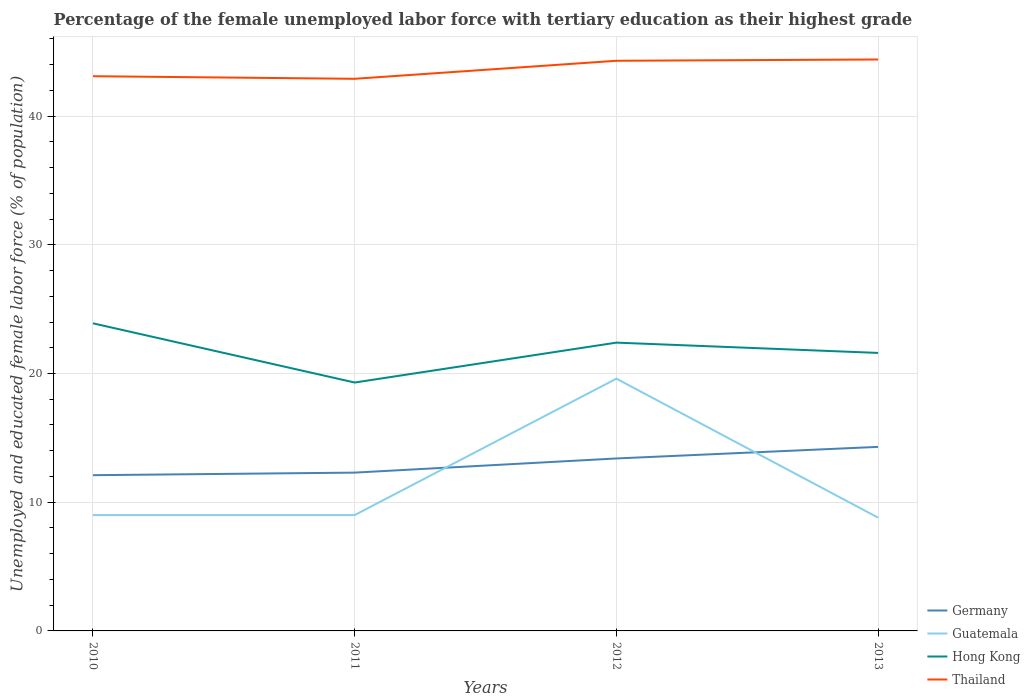How many different coloured lines are there?
Offer a very short reply. 4. Does the line corresponding to Germany intersect with the line corresponding to Thailand?
Keep it short and to the point. No. Is the number of lines equal to the number of legend labels?
Provide a short and direct response. Yes. Across all years, what is the maximum percentage of the unemployed female labor force with tertiary education in Hong Kong?
Provide a short and direct response. 19.3. What is the total percentage of the unemployed female labor force with tertiary education in Germany in the graph?
Offer a terse response. -0.9. What is the difference between the highest and the lowest percentage of the unemployed female labor force with tertiary education in Thailand?
Ensure brevity in your answer.  2. How many years are there in the graph?
Provide a short and direct response. 4. Are the values on the major ticks of Y-axis written in scientific E-notation?
Make the answer very short. No. Does the graph contain any zero values?
Provide a short and direct response. No. Does the graph contain grids?
Give a very brief answer. Yes. Where does the legend appear in the graph?
Ensure brevity in your answer.  Bottom right. How many legend labels are there?
Your answer should be compact. 4. What is the title of the graph?
Your answer should be very brief. Percentage of the female unemployed labor force with tertiary education as their highest grade. What is the label or title of the X-axis?
Provide a short and direct response. Years. What is the label or title of the Y-axis?
Your response must be concise. Unemployed and educated female labor force (% of population). What is the Unemployed and educated female labor force (% of population) in Germany in 2010?
Keep it short and to the point. 12.1. What is the Unemployed and educated female labor force (% of population) in Guatemala in 2010?
Your answer should be very brief. 9. What is the Unemployed and educated female labor force (% of population) of Hong Kong in 2010?
Your answer should be compact. 23.9. What is the Unemployed and educated female labor force (% of population) of Thailand in 2010?
Your answer should be compact. 43.1. What is the Unemployed and educated female labor force (% of population) in Germany in 2011?
Offer a terse response. 12.3. What is the Unemployed and educated female labor force (% of population) of Hong Kong in 2011?
Your answer should be compact. 19.3. What is the Unemployed and educated female labor force (% of population) of Thailand in 2011?
Your answer should be compact. 42.9. What is the Unemployed and educated female labor force (% of population) of Germany in 2012?
Your answer should be very brief. 13.4. What is the Unemployed and educated female labor force (% of population) in Guatemala in 2012?
Your response must be concise. 19.6. What is the Unemployed and educated female labor force (% of population) in Hong Kong in 2012?
Provide a succinct answer. 22.4. What is the Unemployed and educated female labor force (% of population) of Thailand in 2012?
Your answer should be very brief. 44.3. What is the Unemployed and educated female labor force (% of population) of Germany in 2013?
Keep it short and to the point. 14.3. What is the Unemployed and educated female labor force (% of population) in Guatemala in 2013?
Keep it short and to the point. 8.8. What is the Unemployed and educated female labor force (% of population) in Hong Kong in 2013?
Your response must be concise. 21.6. What is the Unemployed and educated female labor force (% of population) of Thailand in 2013?
Keep it short and to the point. 44.4. Across all years, what is the maximum Unemployed and educated female labor force (% of population) in Germany?
Provide a succinct answer. 14.3. Across all years, what is the maximum Unemployed and educated female labor force (% of population) in Guatemala?
Keep it short and to the point. 19.6. Across all years, what is the maximum Unemployed and educated female labor force (% of population) in Hong Kong?
Keep it short and to the point. 23.9. Across all years, what is the maximum Unemployed and educated female labor force (% of population) of Thailand?
Your answer should be very brief. 44.4. Across all years, what is the minimum Unemployed and educated female labor force (% of population) of Germany?
Your answer should be compact. 12.1. Across all years, what is the minimum Unemployed and educated female labor force (% of population) in Guatemala?
Make the answer very short. 8.8. Across all years, what is the minimum Unemployed and educated female labor force (% of population) of Hong Kong?
Offer a terse response. 19.3. Across all years, what is the minimum Unemployed and educated female labor force (% of population) in Thailand?
Your response must be concise. 42.9. What is the total Unemployed and educated female labor force (% of population) in Germany in the graph?
Your response must be concise. 52.1. What is the total Unemployed and educated female labor force (% of population) of Guatemala in the graph?
Give a very brief answer. 46.4. What is the total Unemployed and educated female labor force (% of population) in Hong Kong in the graph?
Your response must be concise. 87.2. What is the total Unemployed and educated female labor force (% of population) in Thailand in the graph?
Your answer should be compact. 174.7. What is the difference between the Unemployed and educated female labor force (% of population) of Germany in 2010 and that in 2011?
Make the answer very short. -0.2. What is the difference between the Unemployed and educated female labor force (% of population) of Guatemala in 2010 and that in 2012?
Make the answer very short. -10.6. What is the difference between the Unemployed and educated female labor force (% of population) in Hong Kong in 2010 and that in 2012?
Offer a very short reply. 1.5. What is the difference between the Unemployed and educated female labor force (% of population) in Thailand in 2010 and that in 2012?
Give a very brief answer. -1.2. What is the difference between the Unemployed and educated female labor force (% of population) of Guatemala in 2010 and that in 2013?
Make the answer very short. 0.2. What is the difference between the Unemployed and educated female labor force (% of population) in Guatemala in 2011 and that in 2012?
Provide a succinct answer. -10.6. What is the difference between the Unemployed and educated female labor force (% of population) in Thailand in 2011 and that in 2012?
Ensure brevity in your answer.  -1.4. What is the difference between the Unemployed and educated female labor force (% of population) in Guatemala in 2011 and that in 2013?
Your answer should be very brief. 0.2. What is the difference between the Unemployed and educated female labor force (% of population) of Hong Kong in 2011 and that in 2013?
Provide a short and direct response. -2.3. What is the difference between the Unemployed and educated female labor force (% of population) in Germany in 2012 and that in 2013?
Ensure brevity in your answer.  -0.9. What is the difference between the Unemployed and educated female labor force (% of population) in Guatemala in 2012 and that in 2013?
Offer a very short reply. 10.8. What is the difference between the Unemployed and educated female labor force (% of population) of Hong Kong in 2012 and that in 2013?
Provide a short and direct response. 0.8. What is the difference between the Unemployed and educated female labor force (% of population) of Germany in 2010 and the Unemployed and educated female labor force (% of population) of Thailand in 2011?
Ensure brevity in your answer.  -30.8. What is the difference between the Unemployed and educated female labor force (% of population) of Guatemala in 2010 and the Unemployed and educated female labor force (% of population) of Thailand in 2011?
Your answer should be very brief. -33.9. What is the difference between the Unemployed and educated female labor force (% of population) of Germany in 2010 and the Unemployed and educated female labor force (% of population) of Hong Kong in 2012?
Give a very brief answer. -10.3. What is the difference between the Unemployed and educated female labor force (% of population) in Germany in 2010 and the Unemployed and educated female labor force (% of population) in Thailand in 2012?
Provide a succinct answer. -32.2. What is the difference between the Unemployed and educated female labor force (% of population) in Guatemala in 2010 and the Unemployed and educated female labor force (% of population) in Thailand in 2012?
Make the answer very short. -35.3. What is the difference between the Unemployed and educated female labor force (% of population) of Hong Kong in 2010 and the Unemployed and educated female labor force (% of population) of Thailand in 2012?
Offer a very short reply. -20.4. What is the difference between the Unemployed and educated female labor force (% of population) in Germany in 2010 and the Unemployed and educated female labor force (% of population) in Guatemala in 2013?
Provide a short and direct response. 3.3. What is the difference between the Unemployed and educated female labor force (% of population) of Germany in 2010 and the Unemployed and educated female labor force (% of population) of Hong Kong in 2013?
Offer a terse response. -9.5. What is the difference between the Unemployed and educated female labor force (% of population) in Germany in 2010 and the Unemployed and educated female labor force (% of population) in Thailand in 2013?
Offer a terse response. -32.3. What is the difference between the Unemployed and educated female labor force (% of population) of Guatemala in 2010 and the Unemployed and educated female labor force (% of population) of Hong Kong in 2013?
Offer a very short reply. -12.6. What is the difference between the Unemployed and educated female labor force (% of population) of Guatemala in 2010 and the Unemployed and educated female labor force (% of population) of Thailand in 2013?
Ensure brevity in your answer.  -35.4. What is the difference between the Unemployed and educated female labor force (% of population) in Hong Kong in 2010 and the Unemployed and educated female labor force (% of population) in Thailand in 2013?
Your response must be concise. -20.5. What is the difference between the Unemployed and educated female labor force (% of population) in Germany in 2011 and the Unemployed and educated female labor force (% of population) in Thailand in 2012?
Offer a very short reply. -32. What is the difference between the Unemployed and educated female labor force (% of population) of Guatemala in 2011 and the Unemployed and educated female labor force (% of population) of Thailand in 2012?
Your answer should be very brief. -35.3. What is the difference between the Unemployed and educated female labor force (% of population) in Hong Kong in 2011 and the Unemployed and educated female labor force (% of population) in Thailand in 2012?
Your answer should be compact. -25. What is the difference between the Unemployed and educated female labor force (% of population) in Germany in 2011 and the Unemployed and educated female labor force (% of population) in Guatemala in 2013?
Offer a terse response. 3.5. What is the difference between the Unemployed and educated female labor force (% of population) in Germany in 2011 and the Unemployed and educated female labor force (% of population) in Thailand in 2013?
Keep it short and to the point. -32.1. What is the difference between the Unemployed and educated female labor force (% of population) in Guatemala in 2011 and the Unemployed and educated female labor force (% of population) in Thailand in 2013?
Offer a very short reply. -35.4. What is the difference between the Unemployed and educated female labor force (% of population) of Hong Kong in 2011 and the Unemployed and educated female labor force (% of population) of Thailand in 2013?
Keep it short and to the point. -25.1. What is the difference between the Unemployed and educated female labor force (% of population) of Germany in 2012 and the Unemployed and educated female labor force (% of population) of Guatemala in 2013?
Offer a very short reply. 4.6. What is the difference between the Unemployed and educated female labor force (% of population) in Germany in 2012 and the Unemployed and educated female labor force (% of population) in Thailand in 2013?
Keep it short and to the point. -31. What is the difference between the Unemployed and educated female labor force (% of population) in Guatemala in 2012 and the Unemployed and educated female labor force (% of population) in Hong Kong in 2013?
Provide a short and direct response. -2. What is the difference between the Unemployed and educated female labor force (% of population) of Guatemala in 2012 and the Unemployed and educated female labor force (% of population) of Thailand in 2013?
Your answer should be very brief. -24.8. What is the average Unemployed and educated female labor force (% of population) in Germany per year?
Offer a very short reply. 13.03. What is the average Unemployed and educated female labor force (% of population) of Hong Kong per year?
Offer a terse response. 21.8. What is the average Unemployed and educated female labor force (% of population) of Thailand per year?
Your answer should be very brief. 43.67. In the year 2010, what is the difference between the Unemployed and educated female labor force (% of population) of Germany and Unemployed and educated female labor force (% of population) of Guatemala?
Keep it short and to the point. 3.1. In the year 2010, what is the difference between the Unemployed and educated female labor force (% of population) of Germany and Unemployed and educated female labor force (% of population) of Thailand?
Make the answer very short. -31. In the year 2010, what is the difference between the Unemployed and educated female labor force (% of population) of Guatemala and Unemployed and educated female labor force (% of population) of Hong Kong?
Give a very brief answer. -14.9. In the year 2010, what is the difference between the Unemployed and educated female labor force (% of population) of Guatemala and Unemployed and educated female labor force (% of population) of Thailand?
Make the answer very short. -34.1. In the year 2010, what is the difference between the Unemployed and educated female labor force (% of population) in Hong Kong and Unemployed and educated female labor force (% of population) in Thailand?
Your answer should be very brief. -19.2. In the year 2011, what is the difference between the Unemployed and educated female labor force (% of population) in Germany and Unemployed and educated female labor force (% of population) in Hong Kong?
Your response must be concise. -7. In the year 2011, what is the difference between the Unemployed and educated female labor force (% of population) of Germany and Unemployed and educated female labor force (% of population) of Thailand?
Make the answer very short. -30.6. In the year 2011, what is the difference between the Unemployed and educated female labor force (% of population) of Guatemala and Unemployed and educated female labor force (% of population) of Hong Kong?
Offer a very short reply. -10.3. In the year 2011, what is the difference between the Unemployed and educated female labor force (% of population) in Guatemala and Unemployed and educated female labor force (% of population) in Thailand?
Give a very brief answer. -33.9. In the year 2011, what is the difference between the Unemployed and educated female labor force (% of population) in Hong Kong and Unemployed and educated female labor force (% of population) in Thailand?
Your answer should be very brief. -23.6. In the year 2012, what is the difference between the Unemployed and educated female labor force (% of population) in Germany and Unemployed and educated female labor force (% of population) in Guatemala?
Ensure brevity in your answer.  -6.2. In the year 2012, what is the difference between the Unemployed and educated female labor force (% of population) of Germany and Unemployed and educated female labor force (% of population) of Hong Kong?
Provide a short and direct response. -9. In the year 2012, what is the difference between the Unemployed and educated female labor force (% of population) of Germany and Unemployed and educated female labor force (% of population) of Thailand?
Offer a terse response. -30.9. In the year 2012, what is the difference between the Unemployed and educated female labor force (% of population) in Guatemala and Unemployed and educated female labor force (% of population) in Hong Kong?
Provide a succinct answer. -2.8. In the year 2012, what is the difference between the Unemployed and educated female labor force (% of population) of Guatemala and Unemployed and educated female labor force (% of population) of Thailand?
Your response must be concise. -24.7. In the year 2012, what is the difference between the Unemployed and educated female labor force (% of population) in Hong Kong and Unemployed and educated female labor force (% of population) in Thailand?
Give a very brief answer. -21.9. In the year 2013, what is the difference between the Unemployed and educated female labor force (% of population) of Germany and Unemployed and educated female labor force (% of population) of Guatemala?
Your response must be concise. 5.5. In the year 2013, what is the difference between the Unemployed and educated female labor force (% of population) in Germany and Unemployed and educated female labor force (% of population) in Hong Kong?
Provide a short and direct response. -7.3. In the year 2013, what is the difference between the Unemployed and educated female labor force (% of population) in Germany and Unemployed and educated female labor force (% of population) in Thailand?
Provide a short and direct response. -30.1. In the year 2013, what is the difference between the Unemployed and educated female labor force (% of population) in Guatemala and Unemployed and educated female labor force (% of population) in Hong Kong?
Ensure brevity in your answer.  -12.8. In the year 2013, what is the difference between the Unemployed and educated female labor force (% of population) of Guatemala and Unemployed and educated female labor force (% of population) of Thailand?
Ensure brevity in your answer.  -35.6. In the year 2013, what is the difference between the Unemployed and educated female labor force (% of population) of Hong Kong and Unemployed and educated female labor force (% of population) of Thailand?
Your answer should be compact. -22.8. What is the ratio of the Unemployed and educated female labor force (% of population) in Germany in 2010 to that in 2011?
Your response must be concise. 0.98. What is the ratio of the Unemployed and educated female labor force (% of population) in Hong Kong in 2010 to that in 2011?
Keep it short and to the point. 1.24. What is the ratio of the Unemployed and educated female labor force (% of population) of Thailand in 2010 to that in 2011?
Offer a terse response. 1. What is the ratio of the Unemployed and educated female labor force (% of population) in Germany in 2010 to that in 2012?
Your response must be concise. 0.9. What is the ratio of the Unemployed and educated female labor force (% of population) in Guatemala in 2010 to that in 2012?
Make the answer very short. 0.46. What is the ratio of the Unemployed and educated female labor force (% of population) in Hong Kong in 2010 to that in 2012?
Give a very brief answer. 1.07. What is the ratio of the Unemployed and educated female labor force (% of population) in Thailand in 2010 to that in 2012?
Offer a very short reply. 0.97. What is the ratio of the Unemployed and educated female labor force (% of population) in Germany in 2010 to that in 2013?
Your answer should be very brief. 0.85. What is the ratio of the Unemployed and educated female labor force (% of population) in Guatemala in 2010 to that in 2013?
Your answer should be very brief. 1.02. What is the ratio of the Unemployed and educated female labor force (% of population) in Hong Kong in 2010 to that in 2013?
Give a very brief answer. 1.11. What is the ratio of the Unemployed and educated female labor force (% of population) in Thailand in 2010 to that in 2013?
Your response must be concise. 0.97. What is the ratio of the Unemployed and educated female labor force (% of population) in Germany in 2011 to that in 2012?
Give a very brief answer. 0.92. What is the ratio of the Unemployed and educated female labor force (% of population) of Guatemala in 2011 to that in 2012?
Your response must be concise. 0.46. What is the ratio of the Unemployed and educated female labor force (% of population) in Hong Kong in 2011 to that in 2012?
Keep it short and to the point. 0.86. What is the ratio of the Unemployed and educated female labor force (% of population) of Thailand in 2011 to that in 2012?
Your answer should be very brief. 0.97. What is the ratio of the Unemployed and educated female labor force (% of population) in Germany in 2011 to that in 2013?
Offer a very short reply. 0.86. What is the ratio of the Unemployed and educated female labor force (% of population) in Guatemala in 2011 to that in 2013?
Provide a short and direct response. 1.02. What is the ratio of the Unemployed and educated female labor force (% of population) in Hong Kong in 2011 to that in 2013?
Give a very brief answer. 0.89. What is the ratio of the Unemployed and educated female labor force (% of population) of Thailand in 2011 to that in 2013?
Make the answer very short. 0.97. What is the ratio of the Unemployed and educated female labor force (% of population) of Germany in 2012 to that in 2013?
Make the answer very short. 0.94. What is the ratio of the Unemployed and educated female labor force (% of population) in Guatemala in 2012 to that in 2013?
Ensure brevity in your answer.  2.23. What is the difference between the highest and the lowest Unemployed and educated female labor force (% of population) in Germany?
Make the answer very short. 2.2. What is the difference between the highest and the lowest Unemployed and educated female labor force (% of population) in Guatemala?
Ensure brevity in your answer.  10.8. What is the difference between the highest and the lowest Unemployed and educated female labor force (% of population) of Thailand?
Offer a terse response. 1.5. 